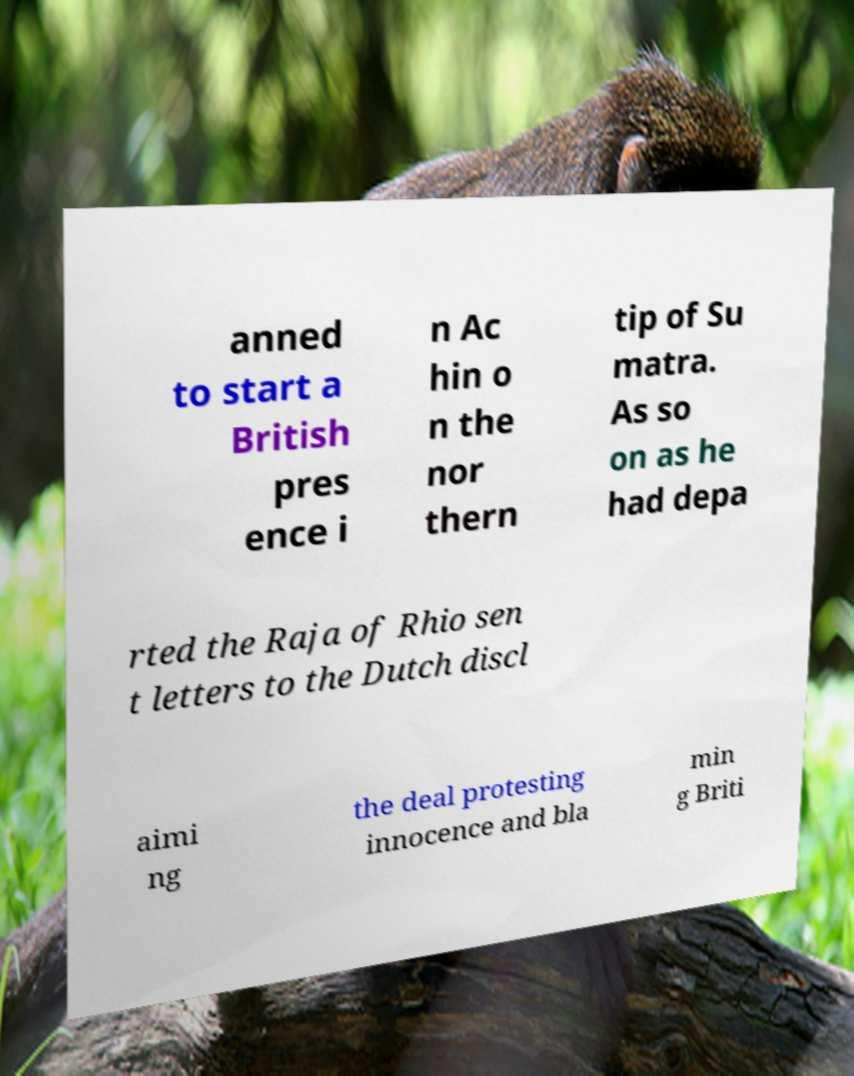I need the written content from this picture converted into text. Can you do that? anned to start a British pres ence i n Ac hin o n the nor thern tip of Su matra. As so on as he had depa rted the Raja of Rhio sen t letters to the Dutch discl aimi ng the deal protesting innocence and bla min g Briti 